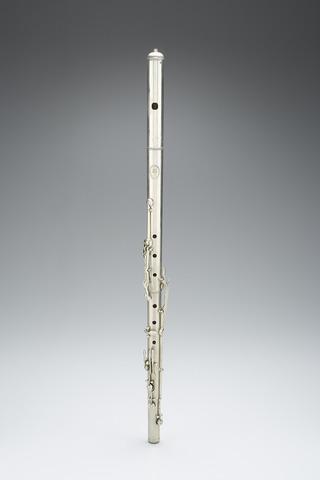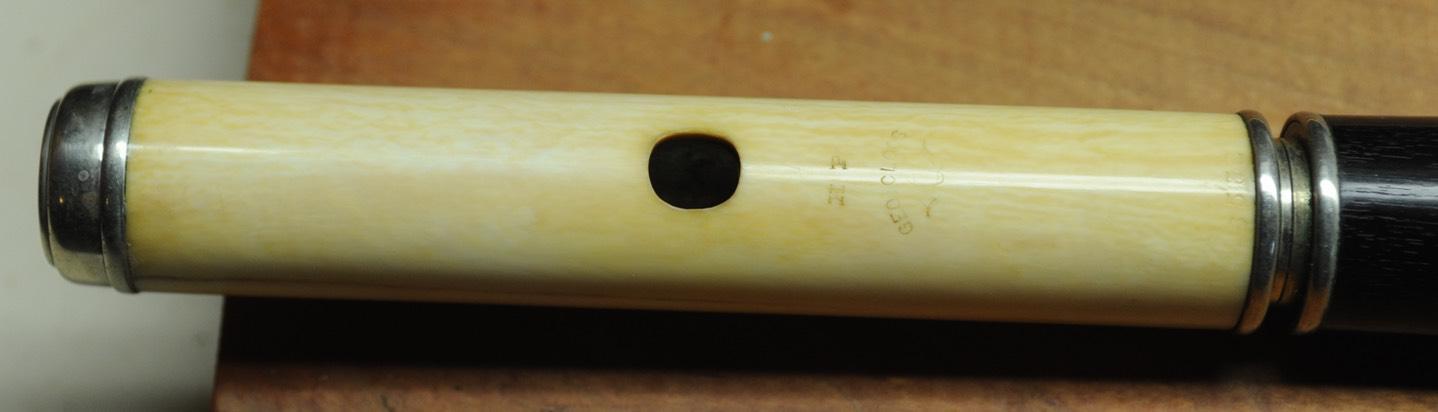The first image is the image on the left, the second image is the image on the right. Considering the images on both sides, is "A flute is oriented vertically." valid? Answer yes or no. Yes. The first image is the image on the left, the second image is the image on the right. Considering the images on both sides, is "The instrument on the left is horizontal, the one on the right is diagonal." valid? Answer yes or no. No. 